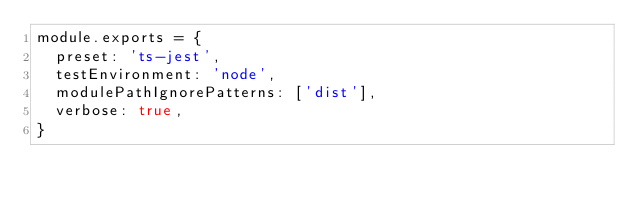<code> <loc_0><loc_0><loc_500><loc_500><_JavaScript_>module.exports = {
  preset: 'ts-jest',
  testEnvironment: 'node',
  modulePathIgnorePatterns: ['dist'],
  verbose: true,
}
</code> 